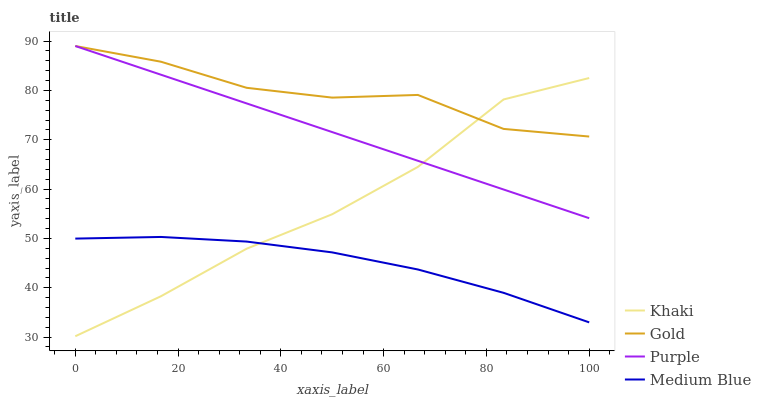Does Medium Blue have the minimum area under the curve?
Answer yes or no. Yes. Does Gold have the maximum area under the curve?
Answer yes or no. Yes. Does Khaki have the minimum area under the curve?
Answer yes or no. No. Does Khaki have the maximum area under the curve?
Answer yes or no. No. Is Purple the smoothest?
Answer yes or no. Yes. Is Gold the roughest?
Answer yes or no. Yes. Is Khaki the smoothest?
Answer yes or no. No. Is Khaki the roughest?
Answer yes or no. No. Does Khaki have the lowest value?
Answer yes or no. Yes. Does Medium Blue have the lowest value?
Answer yes or no. No. Does Gold have the highest value?
Answer yes or no. Yes. Does Khaki have the highest value?
Answer yes or no. No. Is Medium Blue less than Gold?
Answer yes or no. Yes. Is Gold greater than Medium Blue?
Answer yes or no. Yes. Does Khaki intersect Gold?
Answer yes or no. Yes. Is Khaki less than Gold?
Answer yes or no. No. Is Khaki greater than Gold?
Answer yes or no. No. Does Medium Blue intersect Gold?
Answer yes or no. No. 